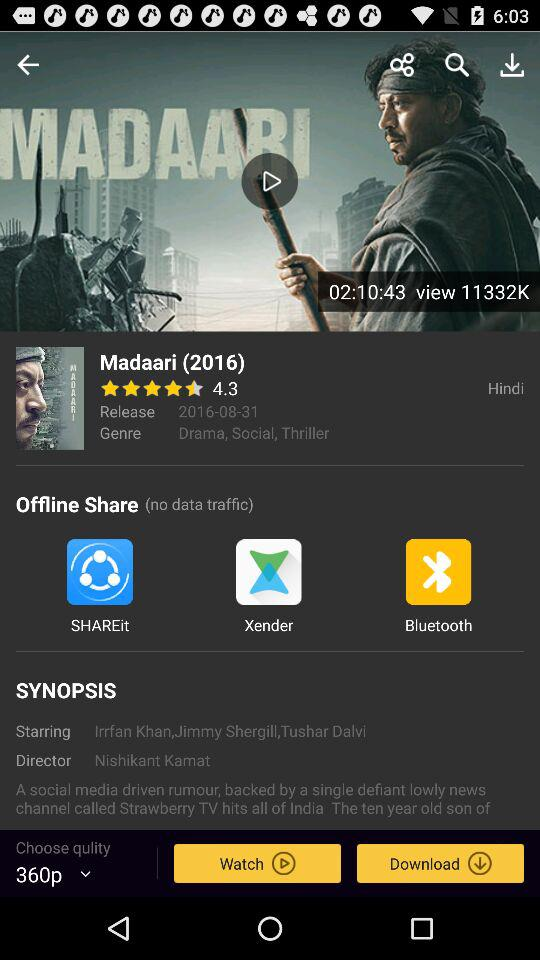What's the release date of "Madaari"? The release date of "Madaari" is August 31, 2016. 